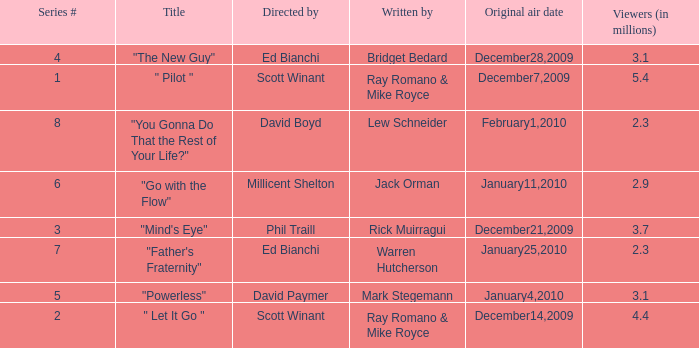What is the episode number of  "you gonna do that the rest of your life?" 8.0. 